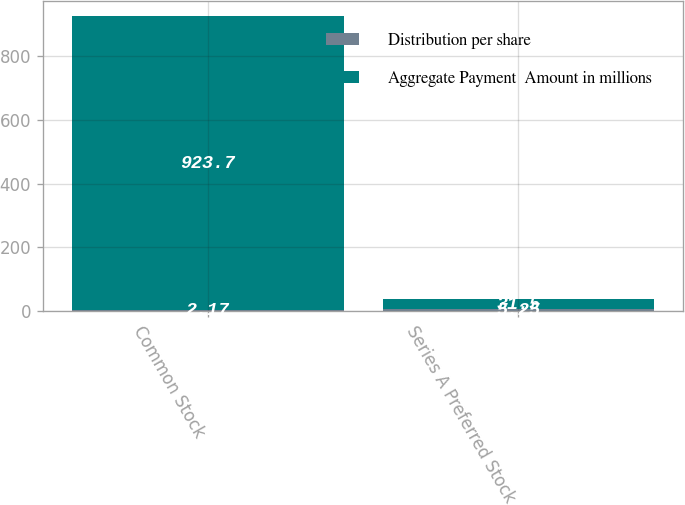Convert chart to OTSL. <chart><loc_0><loc_0><loc_500><loc_500><stacked_bar_chart><ecel><fcel>Common Stock<fcel>Series A Preferred Stock<nl><fcel>Distribution per share<fcel>2.17<fcel>5.25<nl><fcel>Aggregate Payment  Amount in millions<fcel>923.7<fcel>31.5<nl></chart> 